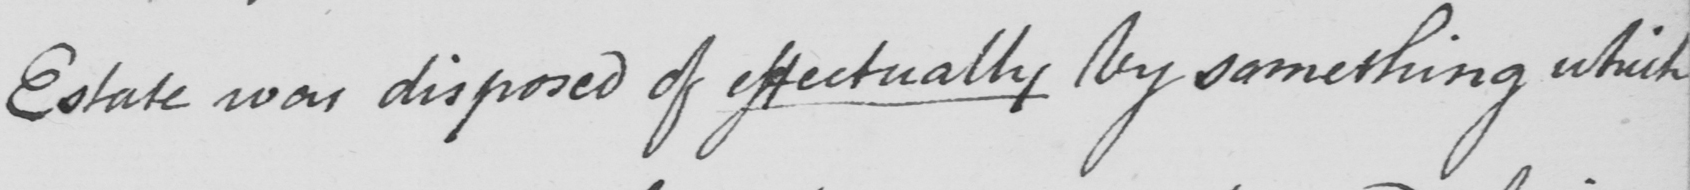What text is written in this handwritten line? Estate was disposed of effectually by something which 